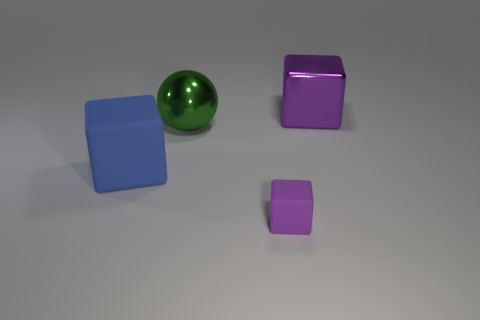There is a thing that is the same color as the small rubber block; what is its shape?
Offer a very short reply. Cube. What number of purple objects are the same size as the green ball?
Offer a very short reply. 1. What number of objects are big objects that are in front of the big sphere or cubes that are to the right of the green metal sphere?
Offer a very short reply. 3. Do the green ball that is on the left side of the small purple object and the purple block that is to the right of the purple matte block have the same material?
Offer a very short reply. Yes. What shape is the purple object behind the matte thing that is behind the small block?
Give a very brief answer. Cube. Are there any other things that are the same color as the metal sphere?
Your response must be concise. No. There is a matte cube to the left of the big metal object on the left side of the large purple cube; is there a purple matte thing that is behind it?
Your answer should be compact. No. Does the rubber object to the right of the blue thing have the same color as the big shiny thing right of the metal ball?
Keep it short and to the point. Yes. What is the material of the other cube that is the same size as the purple metal block?
Offer a very short reply. Rubber. There is a purple thing on the left side of the block that is behind the large object to the left of the green shiny thing; what size is it?
Offer a very short reply. Small. 